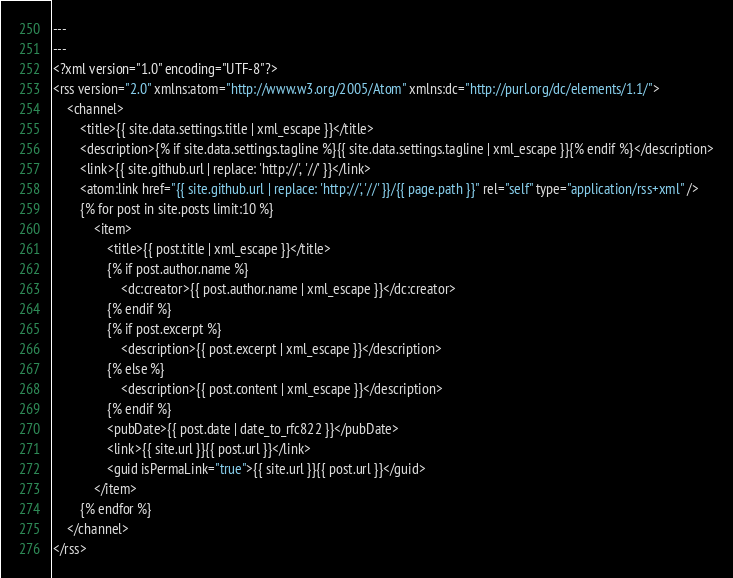<code> <loc_0><loc_0><loc_500><loc_500><_XML_>---
---
<?xml version="1.0" encoding="UTF-8"?>
<rss version="2.0" xmlns:atom="http://www.w3.org/2005/Atom" xmlns:dc="http://purl.org/dc/elements/1.1/">
	<channel>
		<title>{{ site.data.settings.title | xml_escape }}</title>
		<description>{% if site.data.settings.tagline %}{{ site.data.settings.tagline | xml_escape }}{% endif %}</description>
		<link>{{ site.github.url | replace: 'http://', '//' }}</link>
		<atom:link href="{{ site.github.url | replace: 'http://', '//' }}/{{ page.path }}" rel="self" type="application/rss+xml" />
		{% for post in site.posts limit:10 %}
			<item>
				<title>{{ post.title | xml_escape }}</title>
				{% if post.author.name %}
					<dc:creator>{{ post.author.name | xml_escape }}</dc:creator>
				{% endif %}
				{% if post.excerpt %}
					<description>{{ post.excerpt | xml_escape }}</description>
				{% else %}
					<description>{{ post.content | xml_escape }}</description>
				{% endif %}
				<pubDate>{{ post.date | date_to_rfc822 }}</pubDate>
				<link>{{ site.url }}{{ post.url }}</link>
				<guid isPermaLink="true">{{ site.url }}{{ post.url }}</guid>
			</item>
		{% endfor %}
	</channel>
</rss>
</code> 